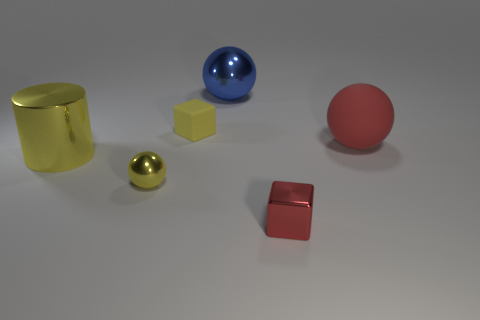Is there anything else that has the same shape as the large yellow shiny object?
Your answer should be very brief. No. The large yellow metallic thing has what shape?
Provide a short and direct response. Cylinder. What is the size of the cube that is the same color as the metal cylinder?
Ensure brevity in your answer.  Small. Is the material of the object behind the tiny yellow rubber object the same as the small yellow sphere?
Offer a terse response. Yes. Is there a tiny rubber block that has the same color as the large matte object?
Keep it short and to the point. No. There is a yellow shiny thing that is in front of the large yellow shiny cylinder; is its shape the same as the matte thing right of the large blue metal sphere?
Ensure brevity in your answer.  Yes. Is there a gray block made of the same material as the yellow ball?
Ensure brevity in your answer.  No. What number of yellow things are either rubber things or small cubes?
Offer a terse response. 1. What is the size of the sphere that is both on the left side of the small red thing and behind the yellow cylinder?
Ensure brevity in your answer.  Large. Is the number of yellow cylinders in front of the large shiny ball greater than the number of small green cubes?
Your answer should be compact. Yes. 